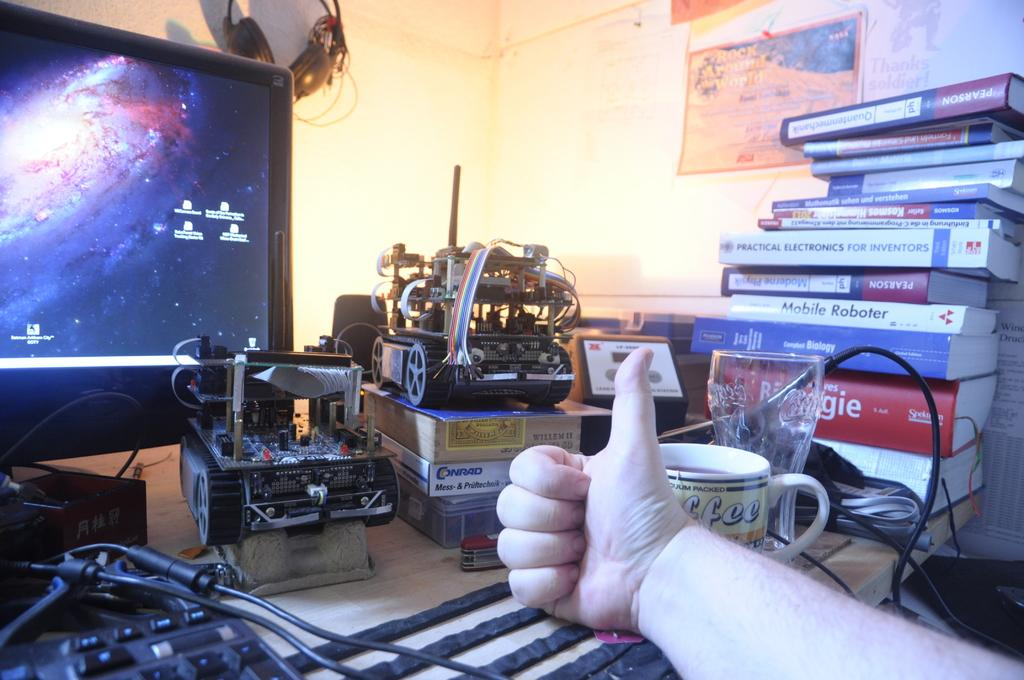<image>
Summarize the visual content of the image. A book called Mobile Roboter sits in a stack of books on someone's desk. 